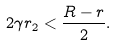<formula> <loc_0><loc_0><loc_500><loc_500>2 \gamma r _ { 2 } < \frac { R - r } { 2 } .</formula> 